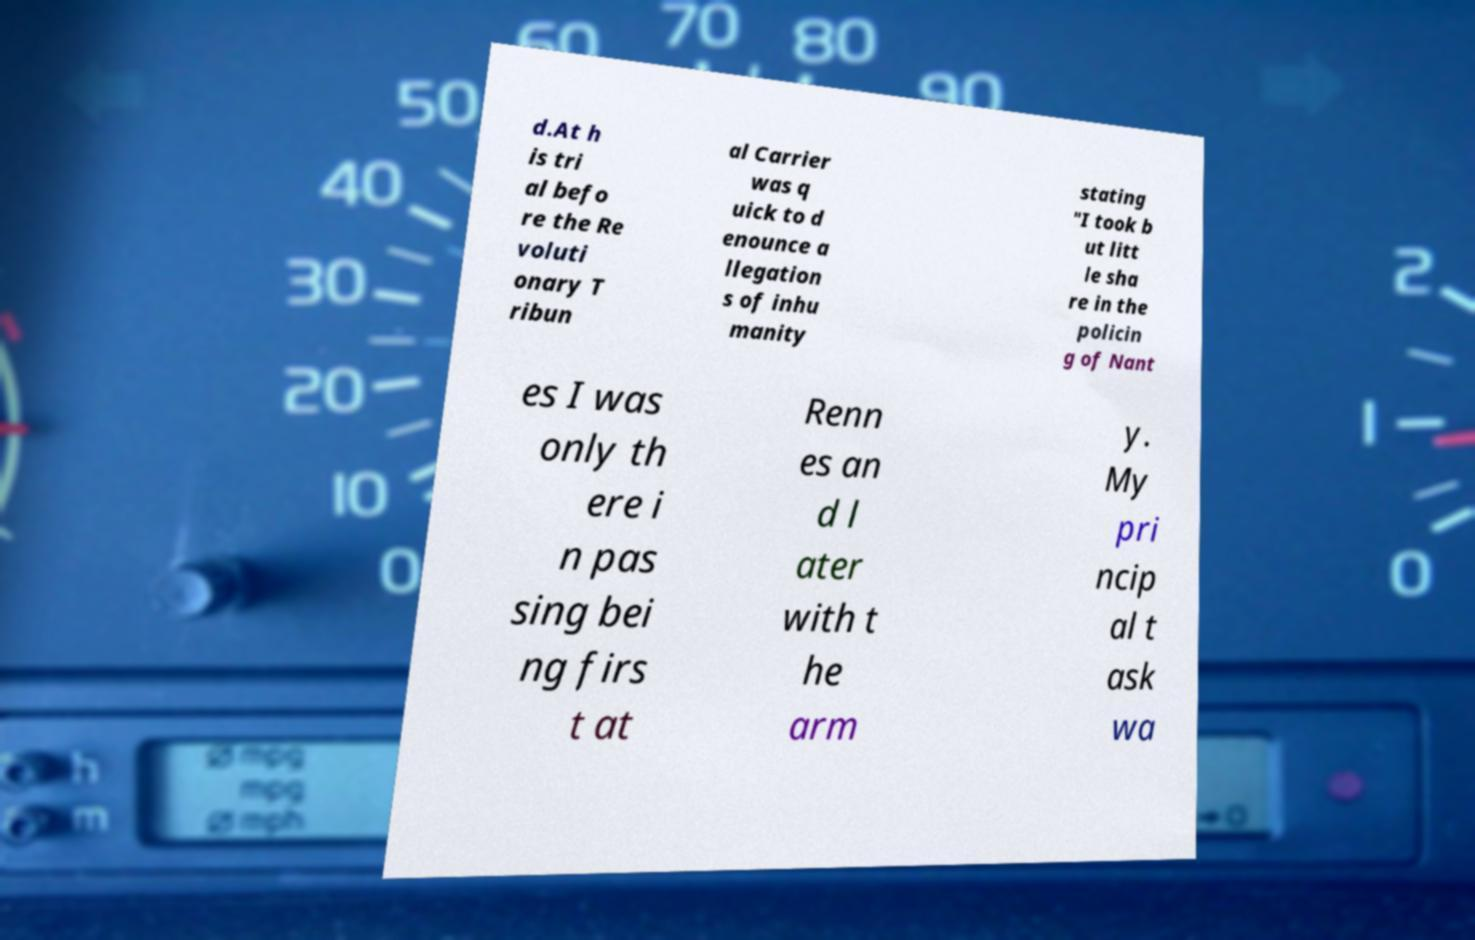For documentation purposes, I need the text within this image transcribed. Could you provide that? d.At h is tri al befo re the Re voluti onary T ribun al Carrier was q uick to d enounce a llegation s of inhu manity stating "I took b ut litt le sha re in the policin g of Nant es I was only th ere i n pas sing bei ng firs t at Renn es an d l ater with t he arm y. My pri ncip al t ask wa 